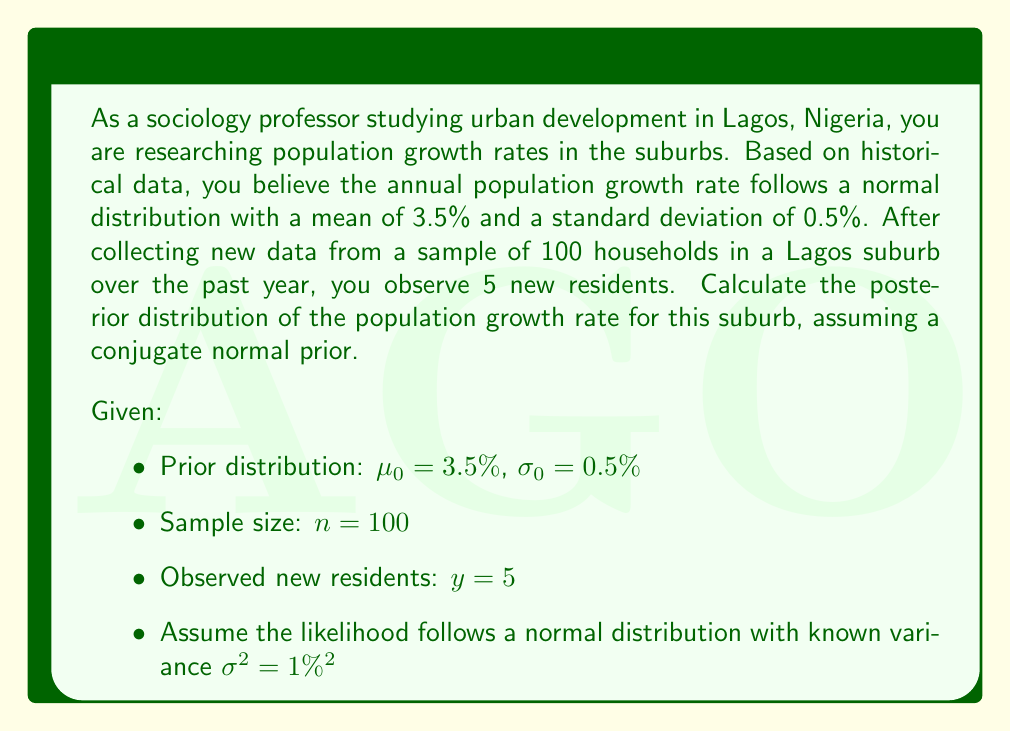Give your solution to this math problem. To solve this problem, we'll use the Bayesian update formula for conjugate normal priors. The steps are as follows:

1) First, we need to convert the prior and likelihood to precision notation:
   Prior precision: $\tau_0 = \frac{1}{\sigma_0^2} = \frac{1}{(0.5\%)^2} = 40000$
   Likelihood precision: $\tau = \frac{1}{\sigma^2} = \frac{1}{(1\%)^2} = 10000$

2) Calculate the sample mean:
   $\bar{y} = \frac{y}{n} = \frac{5}{100} = 5\%$

3) Now we can apply the Bayesian update formulas for the posterior mean ($\mu_n$) and precision ($\tau_n$):

   $$\tau_n = \tau_0 + n\tau = 40000 + 100 \cdot 10000 = 1040000$$

   $$\mu_n = \frac{\tau_0\mu_0 + n\tau\bar{y}}{\tau_n} = \frac{40000 \cdot 3.5\% + 100 \cdot 10000 \cdot 5\%}{1040000} \approx 4.86\%$$

4) Convert the posterior precision back to standard deviation:
   $$\sigma_n = \sqrt{\frac{1}{\tau_n}} = \sqrt{\frac{1}{1040000}} \approx 0.098\%$$

Therefore, the posterior distribution is normal with mean $\mu_n \approx 4.86\%$ and standard deviation $\sigma_n \approx 0.098\%$.
Answer: The posterior distribution of the population growth rate for the Lagos suburb is approximately $N(4.86\%, (0.098\%)^2)$. 